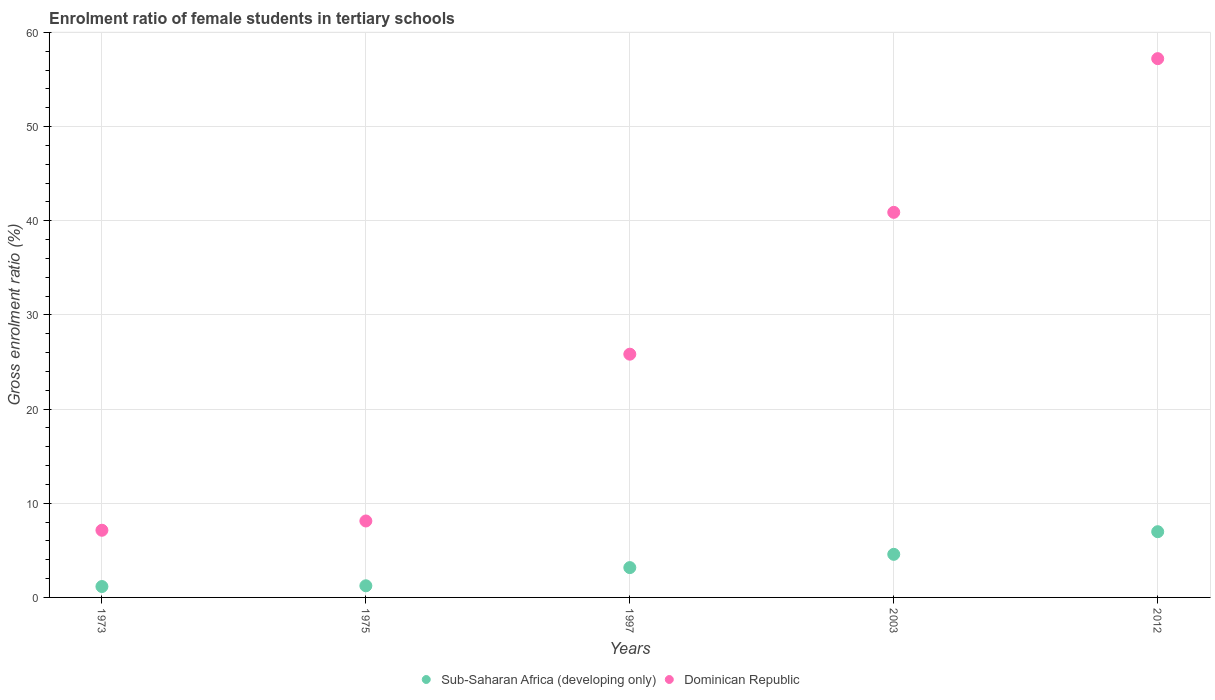How many different coloured dotlines are there?
Offer a very short reply. 2. Is the number of dotlines equal to the number of legend labels?
Give a very brief answer. Yes. What is the enrolment ratio of female students in tertiary schools in Sub-Saharan Africa (developing only) in 2003?
Offer a terse response. 4.58. Across all years, what is the maximum enrolment ratio of female students in tertiary schools in Dominican Republic?
Provide a succinct answer. 57.22. Across all years, what is the minimum enrolment ratio of female students in tertiary schools in Sub-Saharan Africa (developing only)?
Your answer should be compact. 1.16. In which year was the enrolment ratio of female students in tertiary schools in Dominican Republic minimum?
Offer a terse response. 1973. What is the total enrolment ratio of female students in tertiary schools in Dominican Republic in the graph?
Give a very brief answer. 139.2. What is the difference between the enrolment ratio of female students in tertiary schools in Dominican Republic in 1997 and that in 2003?
Your answer should be compact. -15.06. What is the difference between the enrolment ratio of female students in tertiary schools in Dominican Republic in 1997 and the enrolment ratio of female students in tertiary schools in Sub-Saharan Africa (developing only) in 2012?
Offer a terse response. 18.85. What is the average enrolment ratio of female students in tertiary schools in Sub-Saharan Africa (developing only) per year?
Your answer should be compact. 3.42. In the year 2012, what is the difference between the enrolment ratio of female students in tertiary schools in Dominican Republic and enrolment ratio of female students in tertiary schools in Sub-Saharan Africa (developing only)?
Your answer should be compact. 50.24. In how many years, is the enrolment ratio of female students in tertiary schools in Sub-Saharan Africa (developing only) greater than 42 %?
Your answer should be very brief. 0. What is the ratio of the enrolment ratio of female students in tertiary schools in Sub-Saharan Africa (developing only) in 2003 to that in 2012?
Keep it short and to the point. 0.66. What is the difference between the highest and the second highest enrolment ratio of female students in tertiary schools in Sub-Saharan Africa (developing only)?
Provide a succinct answer. 2.4. What is the difference between the highest and the lowest enrolment ratio of female students in tertiary schools in Sub-Saharan Africa (developing only)?
Your response must be concise. 5.82. In how many years, is the enrolment ratio of female students in tertiary schools in Sub-Saharan Africa (developing only) greater than the average enrolment ratio of female students in tertiary schools in Sub-Saharan Africa (developing only) taken over all years?
Ensure brevity in your answer.  2. Is the enrolment ratio of female students in tertiary schools in Sub-Saharan Africa (developing only) strictly less than the enrolment ratio of female students in tertiary schools in Dominican Republic over the years?
Provide a short and direct response. Yes. What is the difference between two consecutive major ticks on the Y-axis?
Keep it short and to the point. 10. What is the title of the graph?
Your answer should be very brief. Enrolment ratio of female students in tertiary schools. Does "Dominican Republic" appear as one of the legend labels in the graph?
Make the answer very short. Yes. What is the label or title of the X-axis?
Give a very brief answer. Years. What is the Gross enrolment ratio (%) of Sub-Saharan Africa (developing only) in 1973?
Your response must be concise. 1.16. What is the Gross enrolment ratio (%) of Dominican Republic in 1973?
Give a very brief answer. 7.13. What is the Gross enrolment ratio (%) of Sub-Saharan Africa (developing only) in 1975?
Offer a very short reply. 1.24. What is the Gross enrolment ratio (%) of Dominican Republic in 1975?
Give a very brief answer. 8.12. What is the Gross enrolment ratio (%) of Sub-Saharan Africa (developing only) in 1997?
Keep it short and to the point. 3.17. What is the Gross enrolment ratio (%) in Dominican Republic in 1997?
Provide a short and direct response. 25.83. What is the Gross enrolment ratio (%) in Sub-Saharan Africa (developing only) in 2003?
Your answer should be compact. 4.58. What is the Gross enrolment ratio (%) in Dominican Republic in 2003?
Ensure brevity in your answer.  40.9. What is the Gross enrolment ratio (%) of Sub-Saharan Africa (developing only) in 2012?
Offer a terse response. 6.98. What is the Gross enrolment ratio (%) of Dominican Republic in 2012?
Your response must be concise. 57.22. Across all years, what is the maximum Gross enrolment ratio (%) of Sub-Saharan Africa (developing only)?
Provide a short and direct response. 6.98. Across all years, what is the maximum Gross enrolment ratio (%) in Dominican Republic?
Make the answer very short. 57.22. Across all years, what is the minimum Gross enrolment ratio (%) in Sub-Saharan Africa (developing only)?
Keep it short and to the point. 1.16. Across all years, what is the minimum Gross enrolment ratio (%) of Dominican Republic?
Ensure brevity in your answer.  7.13. What is the total Gross enrolment ratio (%) in Sub-Saharan Africa (developing only) in the graph?
Your response must be concise. 17.12. What is the total Gross enrolment ratio (%) of Dominican Republic in the graph?
Provide a short and direct response. 139.2. What is the difference between the Gross enrolment ratio (%) of Sub-Saharan Africa (developing only) in 1973 and that in 1975?
Give a very brief answer. -0.08. What is the difference between the Gross enrolment ratio (%) of Dominican Republic in 1973 and that in 1975?
Give a very brief answer. -0.99. What is the difference between the Gross enrolment ratio (%) in Sub-Saharan Africa (developing only) in 1973 and that in 1997?
Offer a terse response. -2.01. What is the difference between the Gross enrolment ratio (%) in Dominican Republic in 1973 and that in 1997?
Provide a succinct answer. -18.7. What is the difference between the Gross enrolment ratio (%) of Sub-Saharan Africa (developing only) in 1973 and that in 2003?
Ensure brevity in your answer.  -3.42. What is the difference between the Gross enrolment ratio (%) of Dominican Republic in 1973 and that in 2003?
Keep it short and to the point. -33.76. What is the difference between the Gross enrolment ratio (%) in Sub-Saharan Africa (developing only) in 1973 and that in 2012?
Give a very brief answer. -5.82. What is the difference between the Gross enrolment ratio (%) of Dominican Republic in 1973 and that in 2012?
Provide a short and direct response. -50.09. What is the difference between the Gross enrolment ratio (%) of Sub-Saharan Africa (developing only) in 1975 and that in 1997?
Offer a very short reply. -1.93. What is the difference between the Gross enrolment ratio (%) in Dominican Republic in 1975 and that in 1997?
Provide a succinct answer. -17.71. What is the difference between the Gross enrolment ratio (%) of Sub-Saharan Africa (developing only) in 1975 and that in 2003?
Your answer should be very brief. -3.34. What is the difference between the Gross enrolment ratio (%) in Dominican Republic in 1975 and that in 2003?
Give a very brief answer. -32.78. What is the difference between the Gross enrolment ratio (%) in Sub-Saharan Africa (developing only) in 1975 and that in 2012?
Ensure brevity in your answer.  -5.74. What is the difference between the Gross enrolment ratio (%) in Dominican Republic in 1975 and that in 2012?
Offer a very short reply. -49.1. What is the difference between the Gross enrolment ratio (%) in Sub-Saharan Africa (developing only) in 1997 and that in 2003?
Your answer should be compact. -1.41. What is the difference between the Gross enrolment ratio (%) in Dominican Republic in 1997 and that in 2003?
Ensure brevity in your answer.  -15.06. What is the difference between the Gross enrolment ratio (%) in Sub-Saharan Africa (developing only) in 1997 and that in 2012?
Your response must be concise. -3.81. What is the difference between the Gross enrolment ratio (%) of Dominican Republic in 1997 and that in 2012?
Keep it short and to the point. -31.39. What is the difference between the Gross enrolment ratio (%) in Sub-Saharan Africa (developing only) in 2003 and that in 2012?
Keep it short and to the point. -2.4. What is the difference between the Gross enrolment ratio (%) in Dominican Republic in 2003 and that in 2012?
Offer a terse response. -16.32. What is the difference between the Gross enrolment ratio (%) of Sub-Saharan Africa (developing only) in 1973 and the Gross enrolment ratio (%) of Dominican Republic in 1975?
Make the answer very short. -6.96. What is the difference between the Gross enrolment ratio (%) in Sub-Saharan Africa (developing only) in 1973 and the Gross enrolment ratio (%) in Dominican Republic in 1997?
Ensure brevity in your answer.  -24.68. What is the difference between the Gross enrolment ratio (%) of Sub-Saharan Africa (developing only) in 1973 and the Gross enrolment ratio (%) of Dominican Republic in 2003?
Make the answer very short. -39.74. What is the difference between the Gross enrolment ratio (%) of Sub-Saharan Africa (developing only) in 1973 and the Gross enrolment ratio (%) of Dominican Republic in 2012?
Your answer should be compact. -56.06. What is the difference between the Gross enrolment ratio (%) in Sub-Saharan Africa (developing only) in 1975 and the Gross enrolment ratio (%) in Dominican Republic in 1997?
Give a very brief answer. -24.6. What is the difference between the Gross enrolment ratio (%) of Sub-Saharan Africa (developing only) in 1975 and the Gross enrolment ratio (%) of Dominican Republic in 2003?
Offer a very short reply. -39.66. What is the difference between the Gross enrolment ratio (%) in Sub-Saharan Africa (developing only) in 1975 and the Gross enrolment ratio (%) in Dominican Republic in 2012?
Make the answer very short. -55.98. What is the difference between the Gross enrolment ratio (%) in Sub-Saharan Africa (developing only) in 1997 and the Gross enrolment ratio (%) in Dominican Republic in 2003?
Keep it short and to the point. -37.73. What is the difference between the Gross enrolment ratio (%) in Sub-Saharan Africa (developing only) in 1997 and the Gross enrolment ratio (%) in Dominican Republic in 2012?
Your answer should be compact. -54.05. What is the difference between the Gross enrolment ratio (%) in Sub-Saharan Africa (developing only) in 2003 and the Gross enrolment ratio (%) in Dominican Republic in 2012?
Provide a short and direct response. -52.64. What is the average Gross enrolment ratio (%) in Sub-Saharan Africa (developing only) per year?
Your response must be concise. 3.42. What is the average Gross enrolment ratio (%) of Dominican Republic per year?
Give a very brief answer. 27.84. In the year 1973, what is the difference between the Gross enrolment ratio (%) in Sub-Saharan Africa (developing only) and Gross enrolment ratio (%) in Dominican Republic?
Your answer should be very brief. -5.98. In the year 1975, what is the difference between the Gross enrolment ratio (%) of Sub-Saharan Africa (developing only) and Gross enrolment ratio (%) of Dominican Republic?
Ensure brevity in your answer.  -6.88. In the year 1997, what is the difference between the Gross enrolment ratio (%) in Sub-Saharan Africa (developing only) and Gross enrolment ratio (%) in Dominican Republic?
Provide a short and direct response. -22.67. In the year 2003, what is the difference between the Gross enrolment ratio (%) of Sub-Saharan Africa (developing only) and Gross enrolment ratio (%) of Dominican Republic?
Keep it short and to the point. -36.32. In the year 2012, what is the difference between the Gross enrolment ratio (%) of Sub-Saharan Africa (developing only) and Gross enrolment ratio (%) of Dominican Republic?
Keep it short and to the point. -50.24. What is the ratio of the Gross enrolment ratio (%) in Sub-Saharan Africa (developing only) in 1973 to that in 1975?
Your answer should be compact. 0.94. What is the ratio of the Gross enrolment ratio (%) of Dominican Republic in 1973 to that in 1975?
Your answer should be very brief. 0.88. What is the ratio of the Gross enrolment ratio (%) in Sub-Saharan Africa (developing only) in 1973 to that in 1997?
Provide a succinct answer. 0.37. What is the ratio of the Gross enrolment ratio (%) in Dominican Republic in 1973 to that in 1997?
Keep it short and to the point. 0.28. What is the ratio of the Gross enrolment ratio (%) in Sub-Saharan Africa (developing only) in 1973 to that in 2003?
Ensure brevity in your answer.  0.25. What is the ratio of the Gross enrolment ratio (%) of Dominican Republic in 1973 to that in 2003?
Offer a terse response. 0.17. What is the ratio of the Gross enrolment ratio (%) of Sub-Saharan Africa (developing only) in 1973 to that in 2012?
Offer a very short reply. 0.17. What is the ratio of the Gross enrolment ratio (%) in Dominican Republic in 1973 to that in 2012?
Give a very brief answer. 0.12. What is the ratio of the Gross enrolment ratio (%) of Sub-Saharan Africa (developing only) in 1975 to that in 1997?
Make the answer very short. 0.39. What is the ratio of the Gross enrolment ratio (%) of Dominican Republic in 1975 to that in 1997?
Give a very brief answer. 0.31. What is the ratio of the Gross enrolment ratio (%) in Sub-Saharan Africa (developing only) in 1975 to that in 2003?
Provide a succinct answer. 0.27. What is the ratio of the Gross enrolment ratio (%) in Dominican Republic in 1975 to that in 2003?
Provide a short and direct response. 0.2. What is the ratio of the Gross enrolment ratio (%) of Sub-Saharan Africa (developing only) in 1975 to that in 2012?
Offer a terse response. 0.18. What is the ratio of the Gross enrolment ratio (%) in Dominican Republic in 1975 to that in 2012?
Offer a very short reply. 0.14. What is the ratio of the Gross enrolment ratio (%) of Sub-Saharan Africa (developing only) in 1997 to that in 2003?
Make the answer very short. 0.69. What is the ratio of the Gross enrolment ratio (%) in Dominican Republic in 1997 to that in 2003?
Offer a terse response. 0.63. What is the ratio of the Gross enrolment ratio (%) of Sub-Saharan Africa (developing only) in 1997 to that in 2012?
Your answer should be compact. 0.45. What is the ratio of the Gross enrolment ratio (%) in Dominican Republic in 1997 to that in 2012?
Make the answer very short. 0.45. What is the ratio of the Gross enrolment ratio (%) of Sub-Saharan Africa (developing only) in 2003 to that in 2012?
Make the answer very short. 0.66. What is the ratio of the Gross enrolment ratio (%) in Dominican Republic in 2003 to that in 2012?
Offer a very short reply. 0.71. What is the difference between the highest and the second highest Gross enrolment ratio (%) in Sub-Saharan Africa (developing only)?
Keep it short and to the point. 2.4. What is the difference between the highest and the second highest Gross enrolment ratio (%) in Dominican Republic?
Provide a short and direct response. 16.32. What is the difference between the highest and the lowest Gross enrolment ratio (%) of Sub-Saharan Africa (developing only)?
Give a very brief answer. 5.82. What is the difference between the highest and the lowest Gross enrolment ratio (%) of Dominican Republic?
Your answer should be compact. 50.09. 